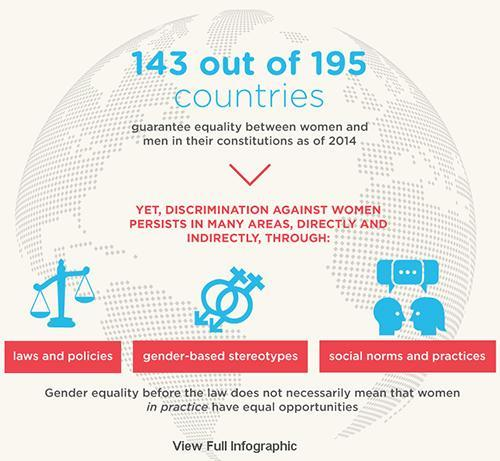which are the areas where discrimination persists
Answer the question with a short phrase. laws and policies, gender-based stereotypes, social norms and practices which area is denoted by the weighing machine laws and policies how many out of 195 countries do not guarantee equality between women and men 52 